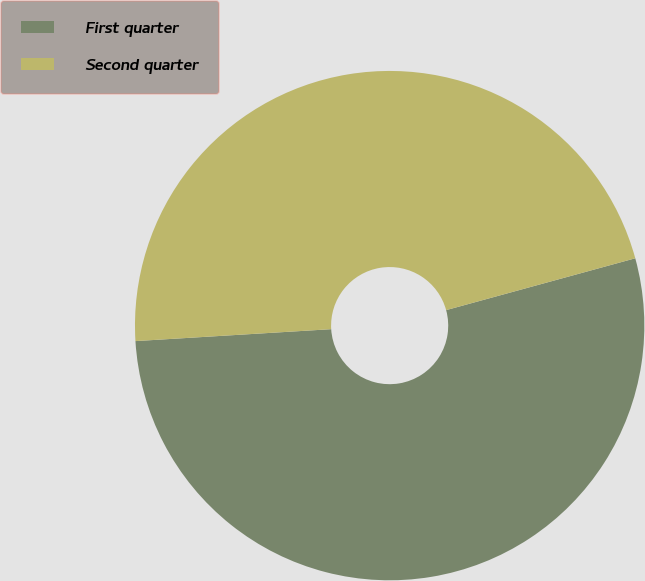Convert chart. <chart><loc_0><loc_0><loc_500><loc_500><pie_chart><fcel>First quarter<fcel>Second quarter<nl><fcel>53.29%<fcel>46.71%<nl></chart> 